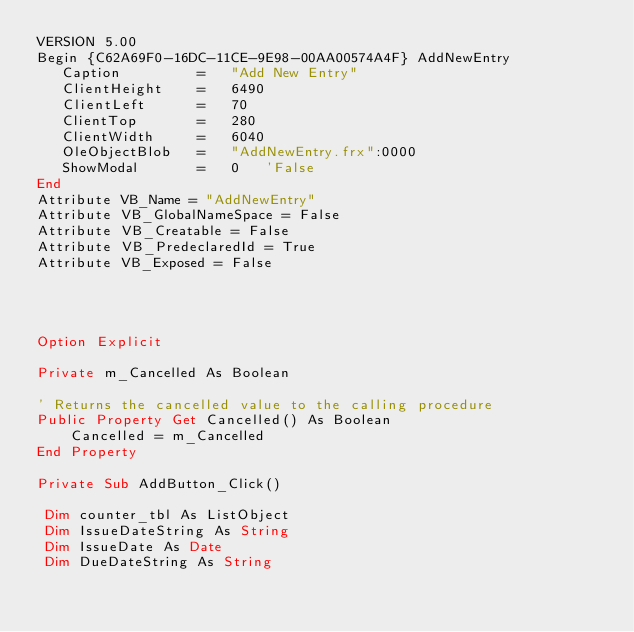Convert code to text. <code><loc_0><loc_0><loc_500><loc_500><_VisualBasic_>VERSION 5.00
Begin {C62A69F0-16DC-11CE-9E98-00AA00574A4F} AddNewEntry 
   Caption         =   "Add New Entry"
   ClientHeight    =   6490
   ClientLeft      =   70
   ClientTop       =   280
   ClientWidth     =   6040
   OleObjectBlob   =   "AddNewEntry.frx":0000
   ShowModal       =   0   'False
End
Attribute VB_Name = "AddNewEntry"
Attribute VB_GlobalNameSpace = False
Attribute VB_Creatable = False
Attribute VB_PredeclaredId = True
Attribute VB_Exposed = False




Option Explicit

Private m_Cancelled As Boolean

' Returns the cancelled value to the calling procedure
Public Property Get Cancelled() As Boolean
    Cancelled = m_Cancelled
End Property

Private Sub AddButton_Click()

 Dim counter_tbl As ListObject
 Dim IssueDateString As String
 Dim IssueDate As Date
 Dim DueDateString As String</code> 